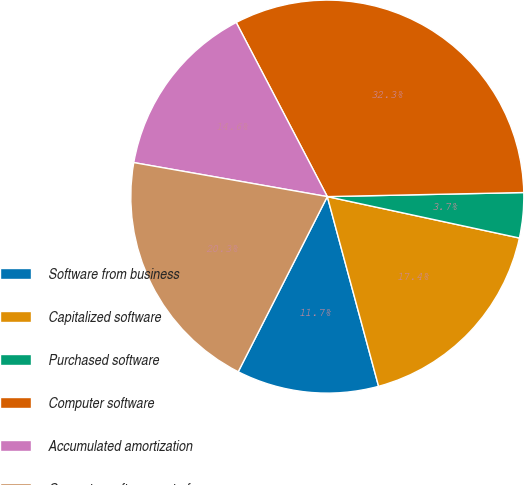Convert chart to OTSL. <chart><loc_0><loc_0><loc_500><loc_500><pie_chart><fcel>Software from business<fcel>Capitalized software<fcel>Purchased software<fcel>Computer software<fcel>Accumulated amortization<fcel>Computer software net of<nl><fcel>11.69%<fcel>17.42%<fcel>3.71%<fcel>32.34%<fcel>14.56%<fcel>20.28%<nl></chart> 